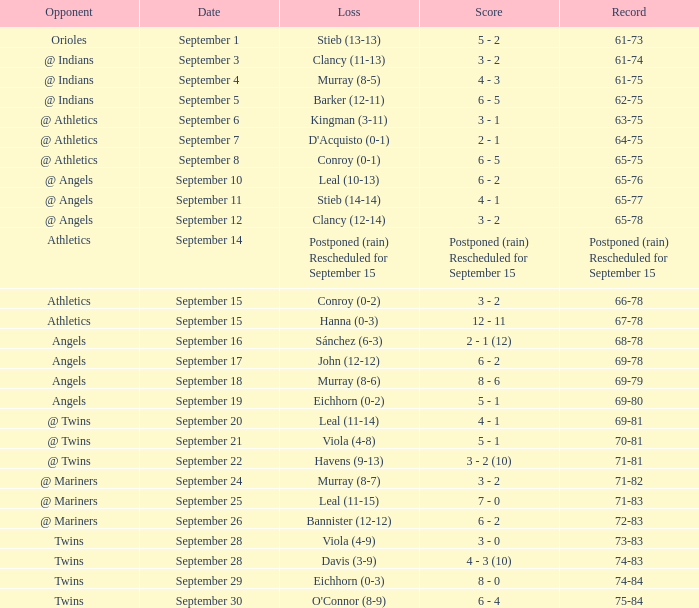Name the date for record of 74-84 September 29. 